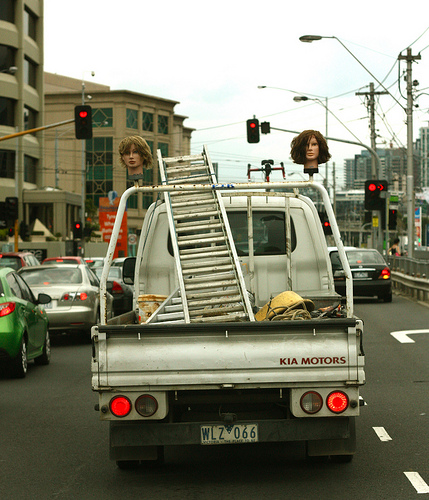<image>
Can you confirm if the stop light is to the right of the head? Yes. From this viewpoint, the stop light is positioned to the right side relative to the head. Is the truck under the ladder? Yes. The truck is positioned underneath the ladder, with the ladder above it in the vertical space. 